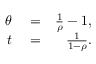<formula> <loc_0><loc_0><loc_500><loc_500>\begin{array} { r l r } { \theta } & = } & { \frac { 1 } { \rho } - 1 , } \\ { t } & = } & { \frac { 1 } { 1 - \rho } . } \end{array}</formula> 